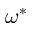<formula> <loc_0><loc_0><loc_500><loc_500>\omega ^ { * }</formula> 